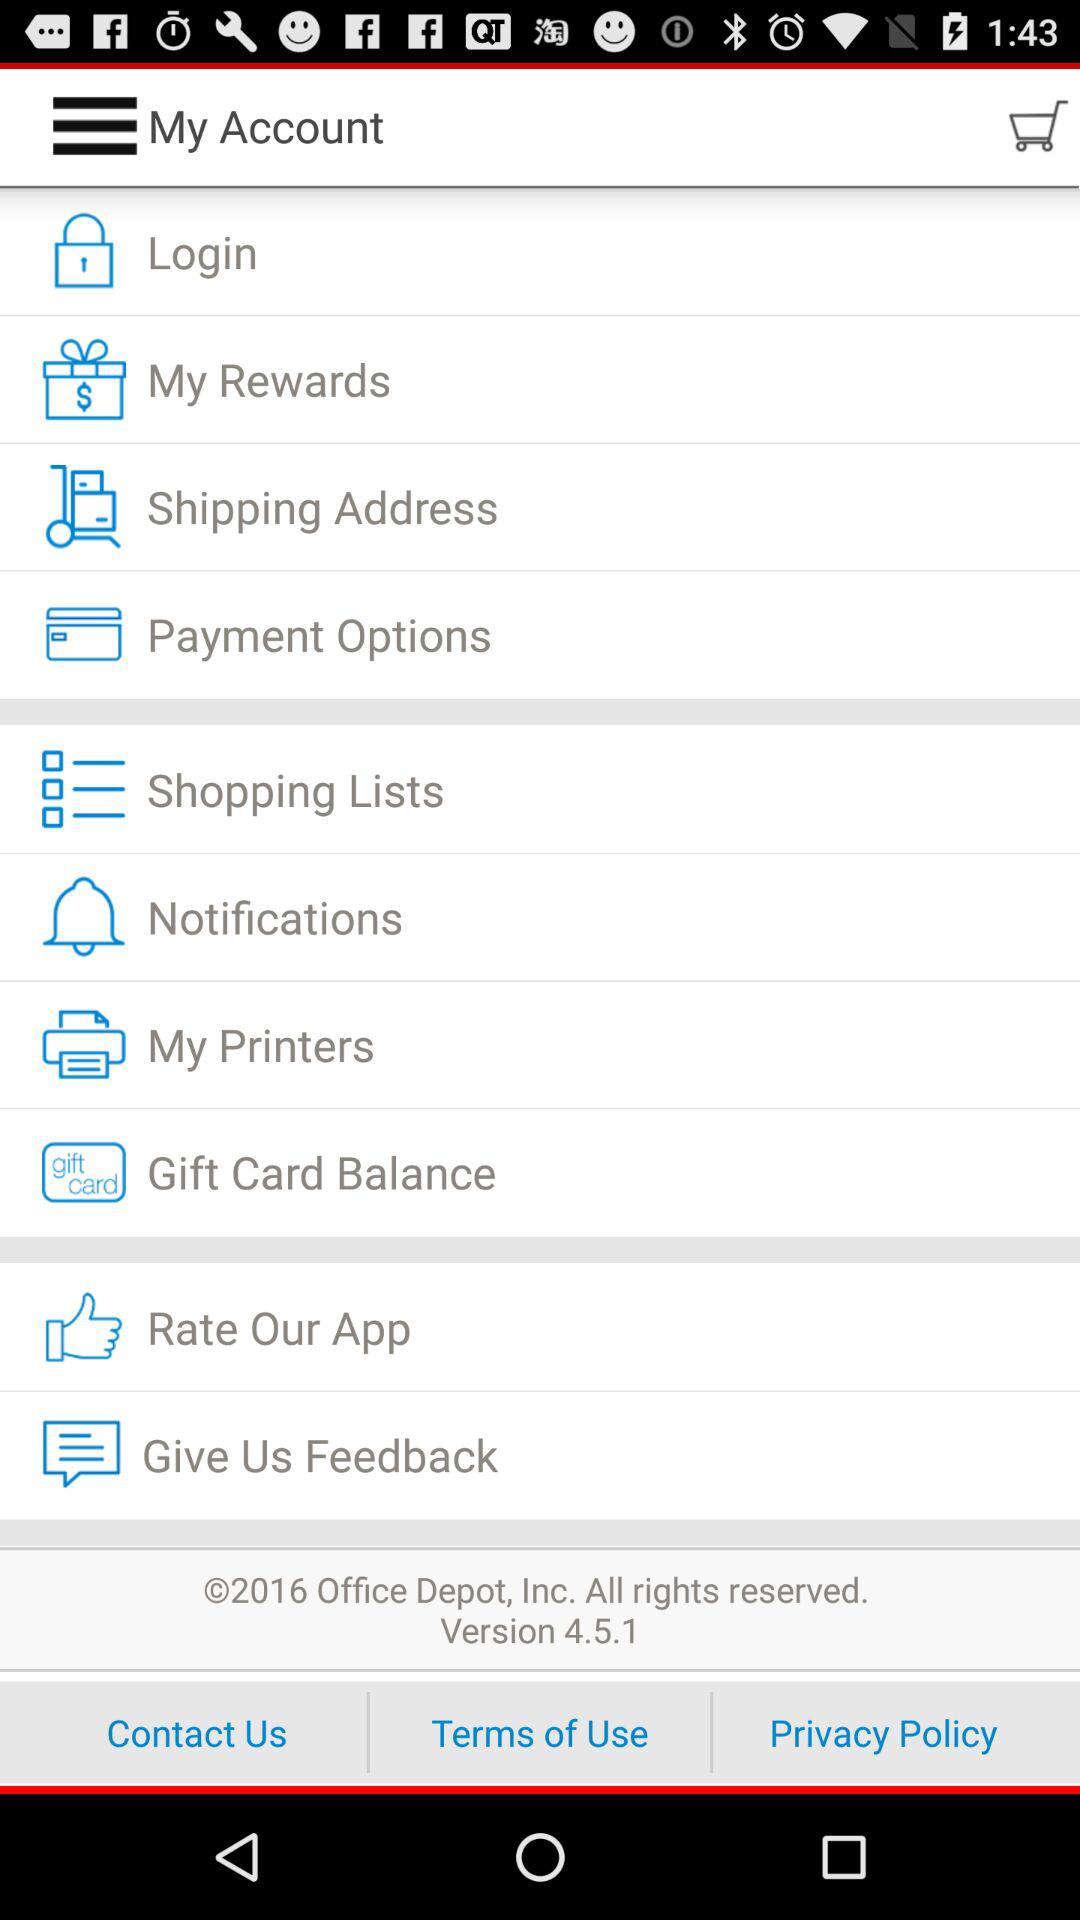What is the version? The version is 4.5.1. 